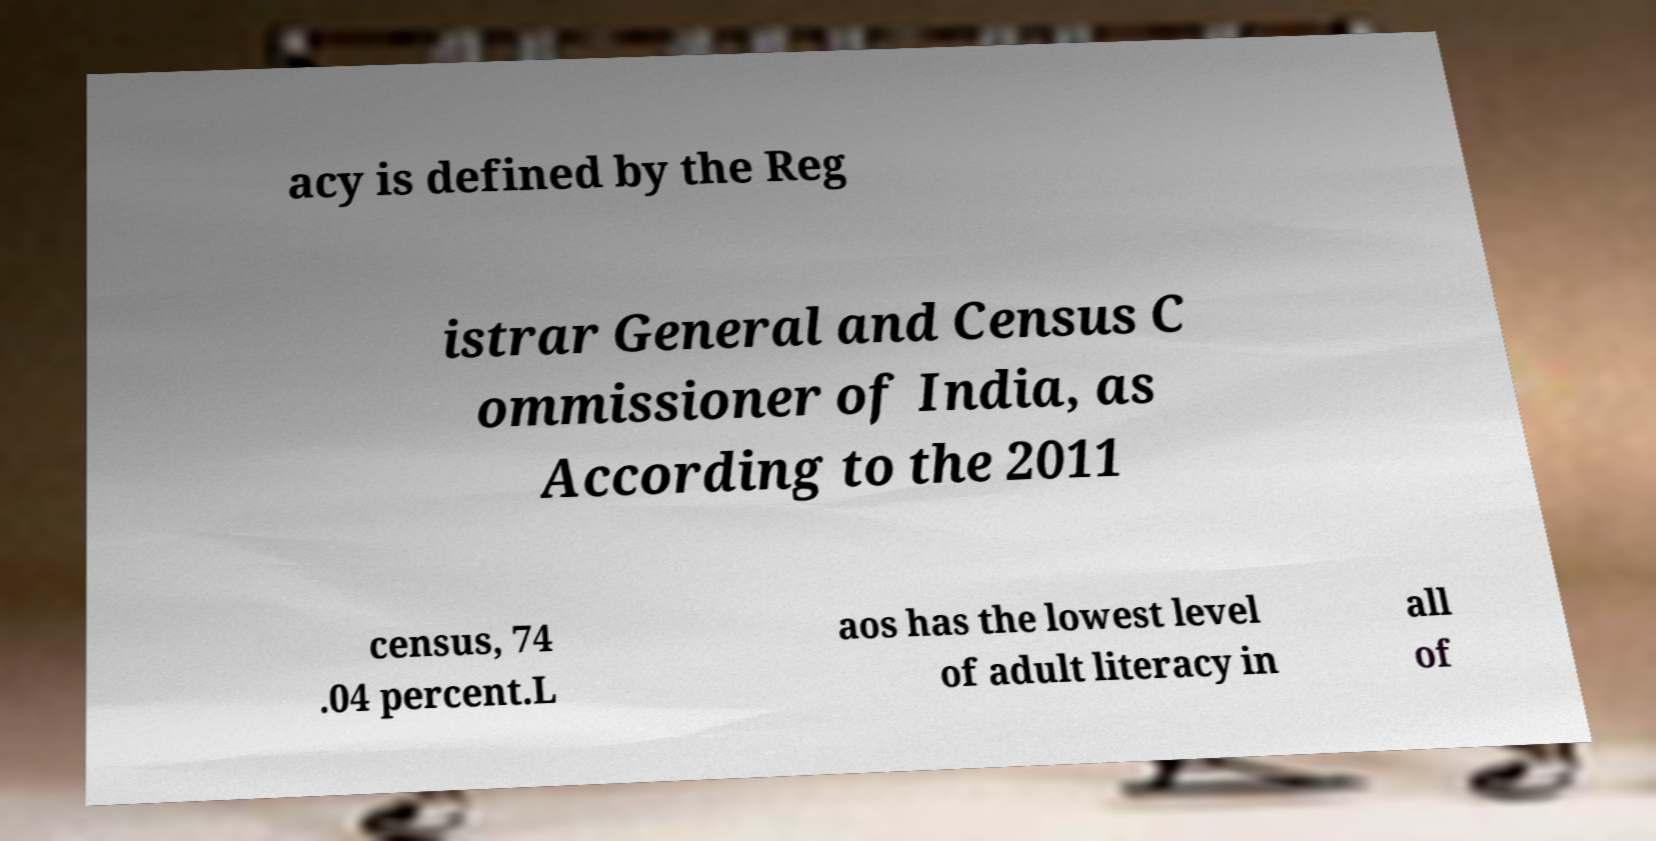Can you read and provide the text displayed in the image?This photo seems to have some interesting text. Can you extract and type it out for me? acy is defined by the Reg istrar General and Census C ommissioner of India, as According to the 2011 census, 74 .04 percent.L aos has the lowest level of adult literacy in all of 